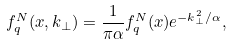<formula> <loc_0><loc_0><loc_500><loc_500>f _ { q } ^ { N } ( x , k _ { \perp } ) = \frac { 1 } { \pi \alpha } f _ { q } ^ { N } ( x ) e ^ { - k _ { \perp } ^ { 2 } / \alpha } ,</formula> 